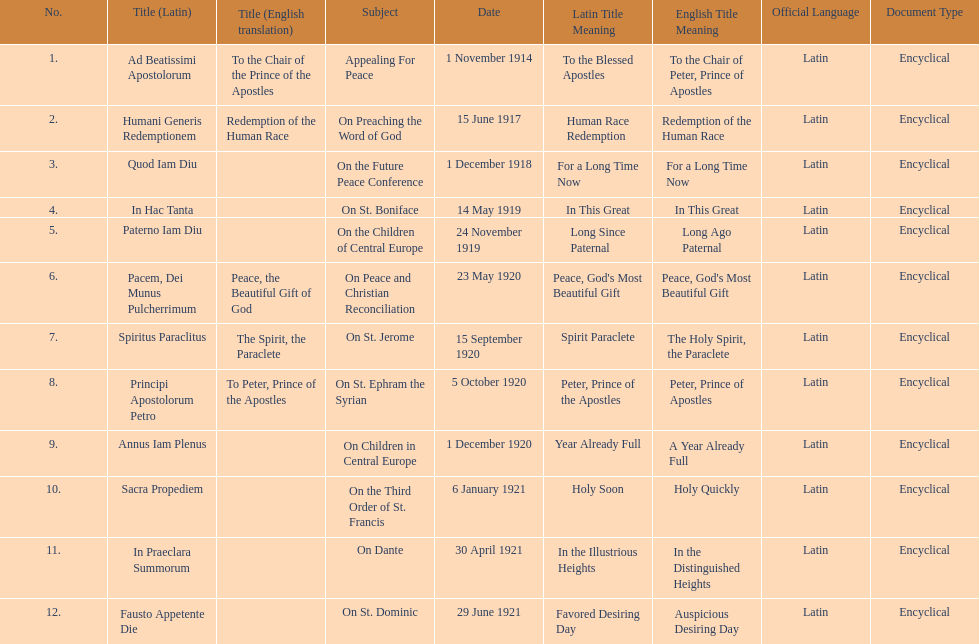What is the only subject on 23 may 1920? On Peace and Christian Reconciliation. 